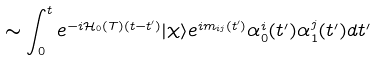<formula> <loc_0><loc_0><loc_500><loc_500>\sim \int _ { 0 } ^ { t } e ^ { - i { \mathcal { H } } _ { 0 } ( T ) ( t - t ^ { \prime } ) } | \chi \rangle e ^ { i m _ { i j } ( t ^ { \prime } ) } \alpha _ { 0 } ^ { i } ( t ^ { \prime } ) \alpha _ { 1 } ^ { j } ( t ^ { \prime } ) d t ^ { \prime } \</formula> 